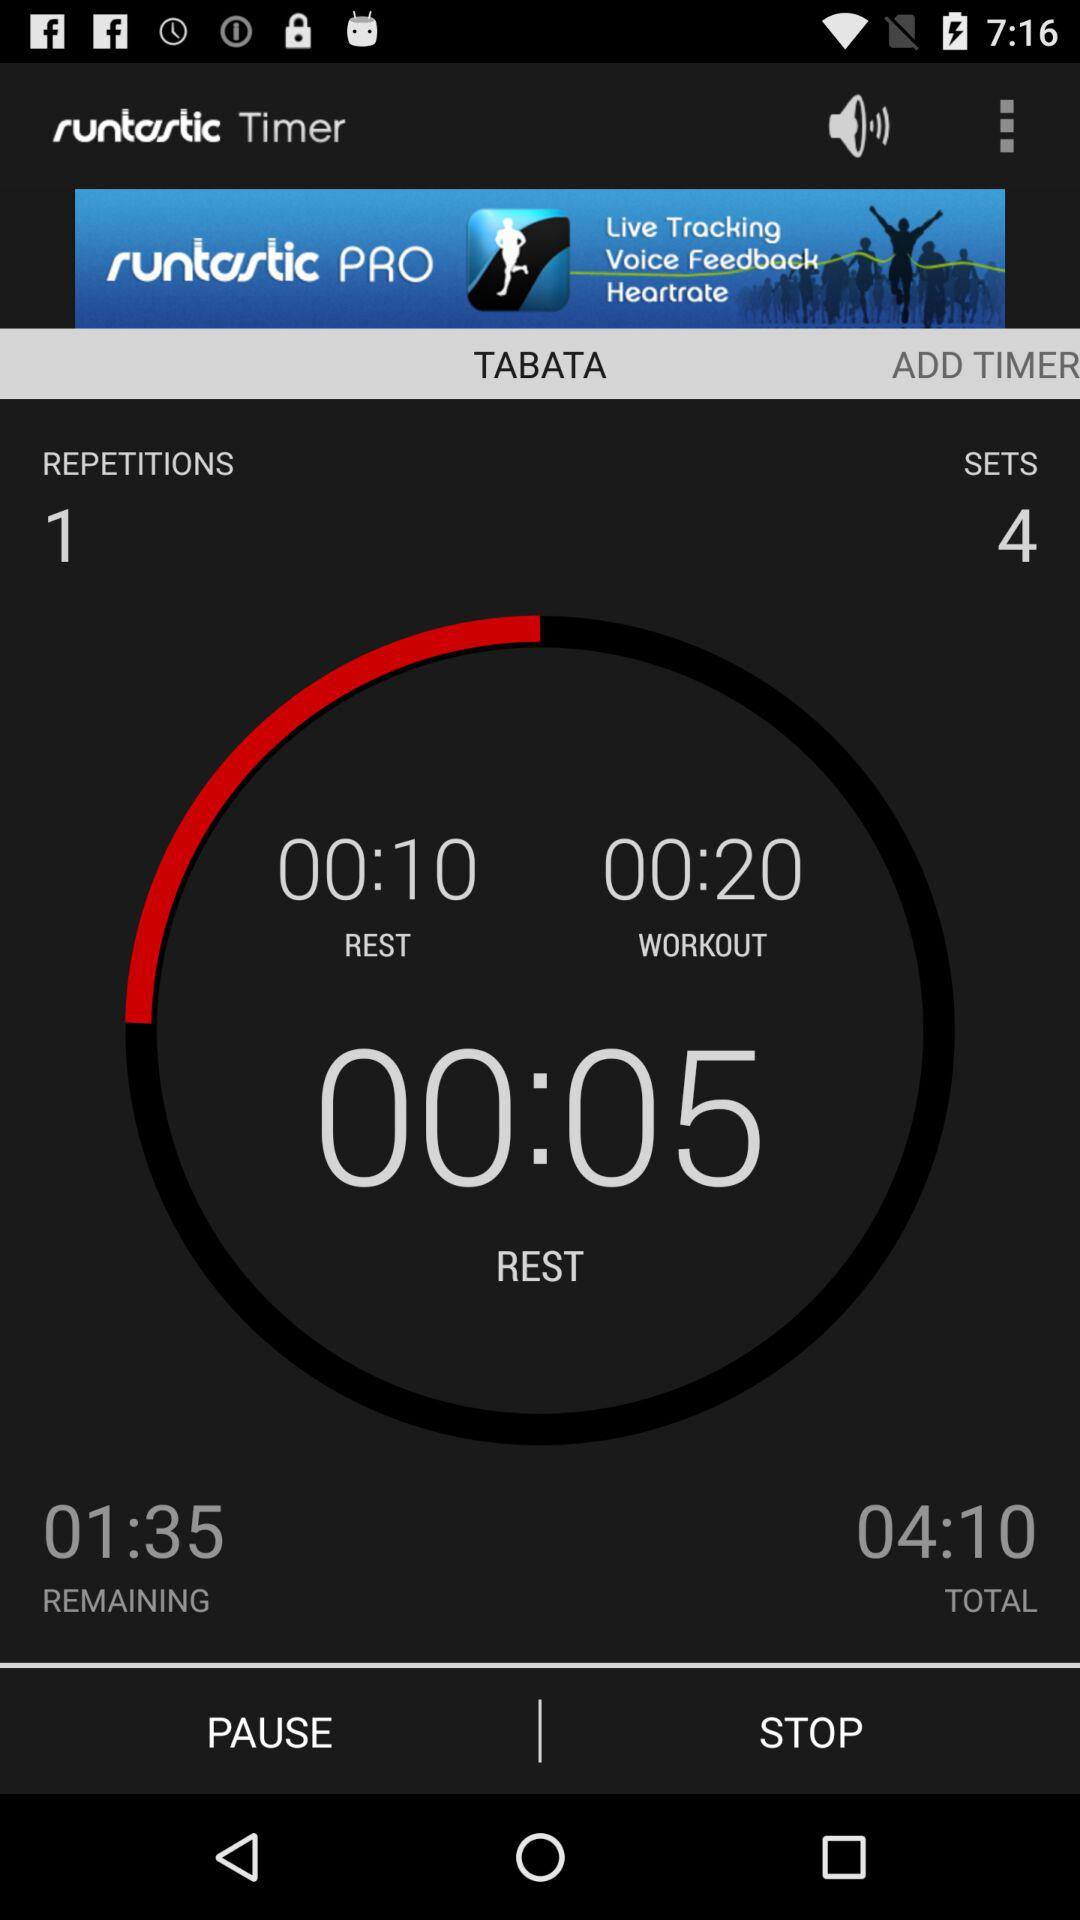What is the total time? The total time is 4 minutes and 10 seconds. 